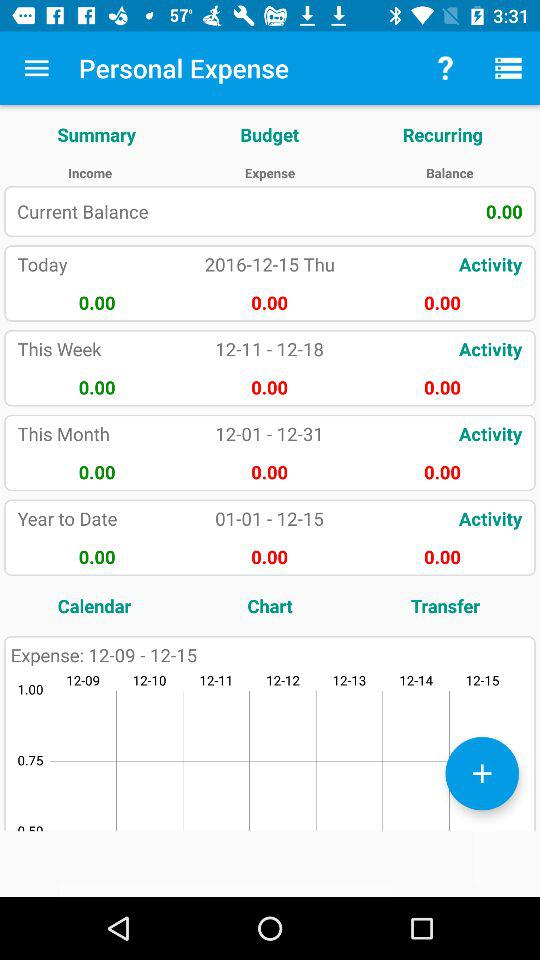What is the current balance in "Personal Expense"? The current balance in "Personal Expense" is 0.00. 